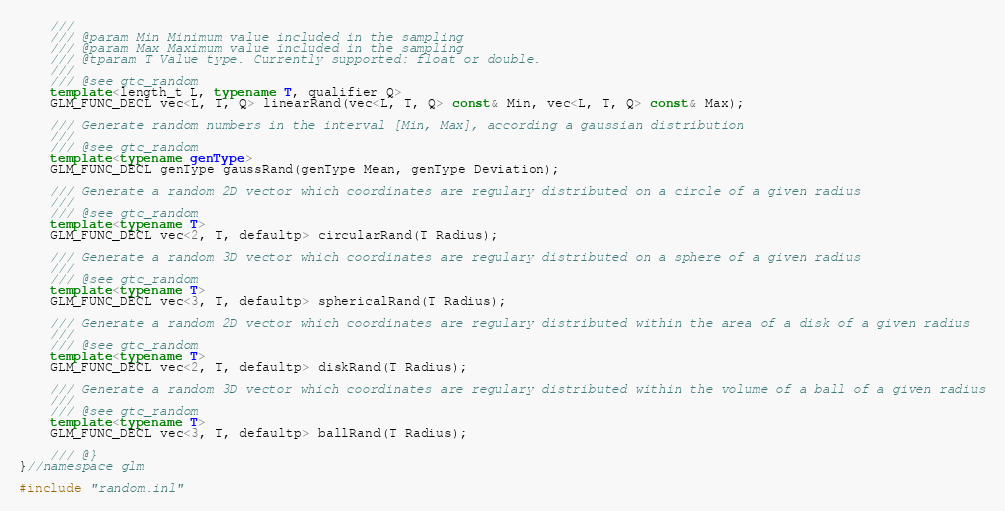Convert code to text. <code><loc_0><loc_0><loc_500><loc_500><_C++_>	///
	/// @param Min Minimum value included in the sampling
	/// @param Max Maximum value included in the sampling
	/// @tparam T Value type. Currently supported: float or double.
	///
	/// @see gtc_random
	template<length_t L, typename T, qualifier Q>
	GLM_FUNC_DECL vec<L, T, Q> linearRand(vec<L, T, Q> const& Min, vec<L, T, Q> const& Max);

	/// Generate random numbers in the interval [Min, Max], according a gaussian distribution
	///
	/// @see gtc_random
	template<typename genType>
	GLM_FUNC_DECL genType gaussRand(genType Mean, genType Deviation);

	/// Generate a random 2D vector which coordinates are regulary distributed on a circle of a given radius
	///
	/// @see gtc_random
	template<typename T>
	GLM_FUNC_DECL vec<2, T, defaultp> circularRand(T Radius);

	/// Generate a random 3D vector which coordinates are regulary distributed on a sphere of a given radius
	///
	/// @see gtc_random
	template<typename T>
	GLM_FUNC_DECL vec<3, T, defaultp> sphericalRand(T Radius);

	/// Generate a random 2D vector which coordinates are regulary distributed within the area of a disk of a given radius
	///
	/// @see gtc_random
	template<typename T>
	GLM_FUNC_DECL vec<2, T, defaultp> diskRand(T Radius);

	/// Generate a random 3D vector which coordinates are regulary distributed within the volume of a ball of a given radius
	///
	/// @see gtc_random
	template<typename T>
	GLM_FUNC_DECL vec<3, T, defaultp> ballRand(T Radius);

	/// @}
}//namespace glm

#include "random.inl"
</code> 